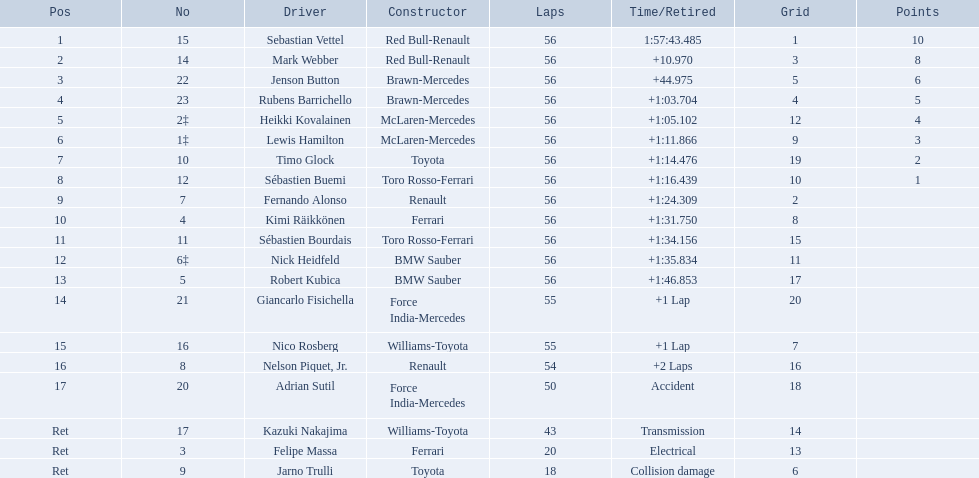Who were all the racers? Sebastian Vettel, Mark Webber, Jenson Button, Rubens Barrichello, Heikki Kovalainen, Lewis Hamilton, Timo Glock, Sébastien Buemi, Fernando Alonso, Kimi Räikkönen, Sébastien Bourdais, Nick Heidfeld, Robert Kubica, Giancarlo Fisichella, Nico Rosberg, Nelson Piquet, Jr., Adrian Sutil, Kazuki Nakajima, Felipe Massa, Jarno Trulli. Which of these didn't have ferrari as a builder? Sebastian Vettel, Mark Webber, Jenson Button, Rubens Barrichello, Heikki Kovalainen, Lewis Hamilton, Timo Glock, Sébastien Buemi, Fernando Alonso, Sébastien Bourdais, Nick Heidfeld, Robert Kubica, Giancarlo Fisichella, Nico Rosberg, Nelson Piquet, Jr., Adrian Sutil, Kazuki Nakajima, Jarno Trulli. Which of these was in the top position? Sebastian Vettel. 